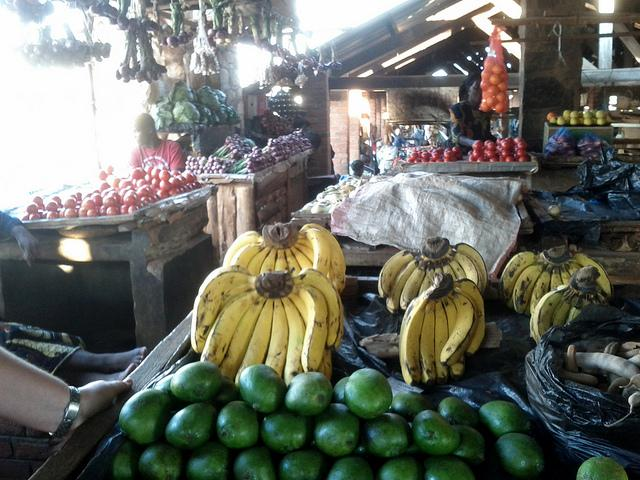What color is the fruit located under the bananas? green 